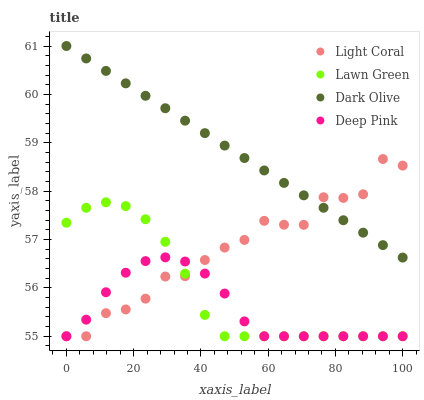Does Deep Pink have the minimum area under the curve?
Answer yes or no. Yes. Does Dark Olive have the maximum area under the curve?
Answer yes or no. Yes. Does Lawn Green have the minimum area under the curve?
Answer yes or no. No. Does Lawn Green have the maximum area under the curve?
Answer yes or no. No. Is Dark Olive the smoothest?
Answer yes or no. Yes. Is Light Coral the roughest?
Answer yes or no. Yes. Is Lawn Green the smoothest?
Answer yes or no. No. Is Lawn Green the roughest?
Answer yes or no. No. Does Light Coral have the lowest value?
Answer yes or no. Yes. Does Dark Olive have the lowest value?
Answer yes or no. No. Does Dark Olive have the highest value?
Answer yes or no. Yes. Does Lawn Green have the highest value?
Answer yes or no. No. Is Lawn Green less than Dark Olive?
Answer yes or no. Yes. Is Dark Olive greater than Deep Pink?
Answer yes or no. Yes. Does Light Coral intersect Dark Olive?
Answer yes or no. Yes. Is Light Coral less than Dark Olive?
Answer yes or no. No. Is Light Coral greater than Dark Olive?
Answer yes or no. No. Does Lawn Green intersect Dark Olive?
Answer yes or no. No. 